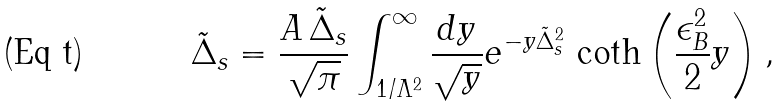Convert formula to latex. <formula><loc_0><loc_0><loc_500><loc_500>\tilde { \Delta } _ { s } = \frac { A \, \tilde { \Delta } _ { s } } { \sqrt { \pi } } \int _ { 1 / \Lambda ^ { 2 } } ^ { \infty } \frac { d y } { \sqrt { y } } e ^ { - y \tilde { \Delta } _ { s } ^ { 2 } } \, \coth \left ( \frac { \epsilon _ { B } ^ { 2 } } { 2 } y \right ) ,</formula> 